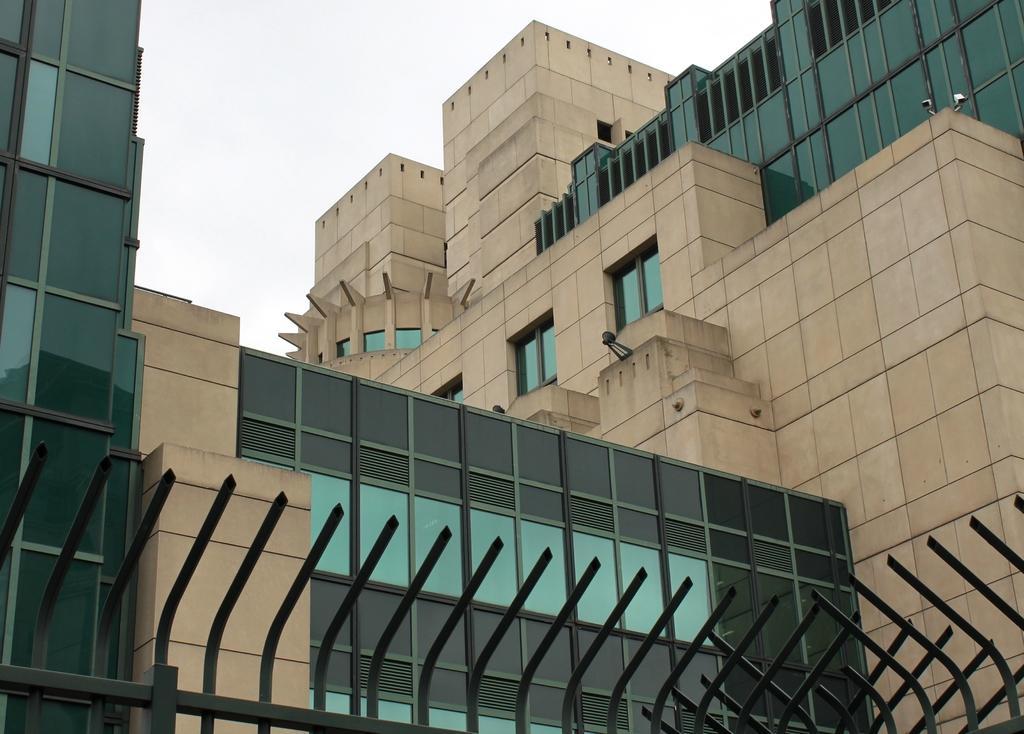Describe this image in one or two sentences. In this image we can see a building with windows. We can also see the sky. In the foreground we can see some metal poles. 